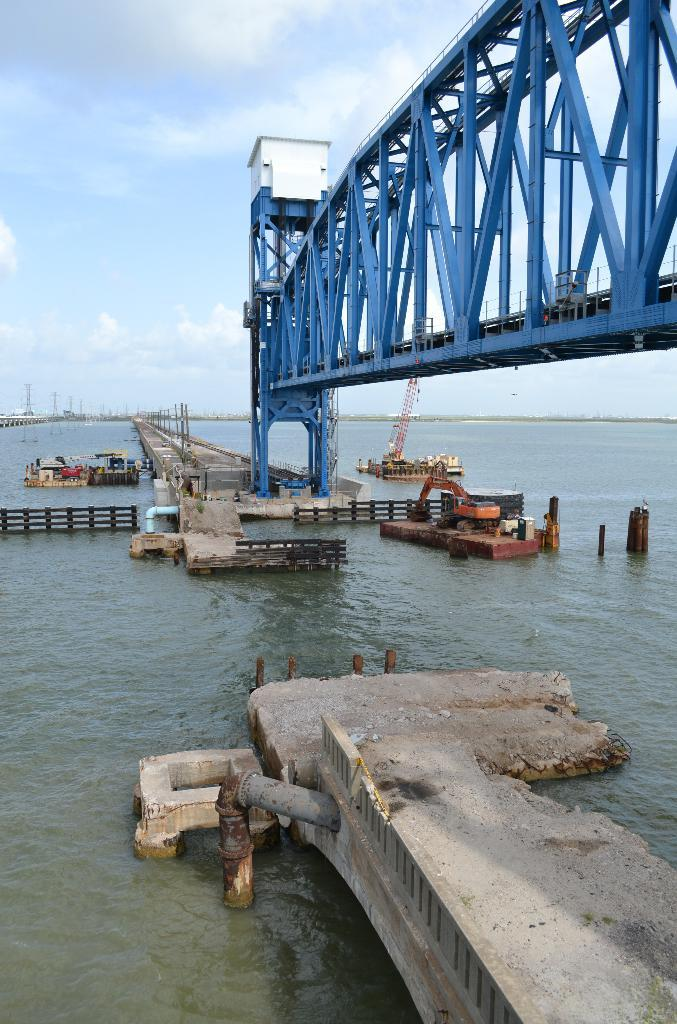What type of structure can be seen in the image? There is a bridge in the image. What else can be seen in the image besides the bridge? Pipes, a fence, and a crane are visible in the image. What is the condition of the water in the image? Water is visible in the image. What can be seen in the background of the image? The sky is visible in the background of the image. What is the weather like in the image? Clouds are present in the sky, suggesting a partly cloudy day. What type of hall can be seen in the image? There is no hall present in the image. How many hills are visible in the image? There are no hills visible in the image. 